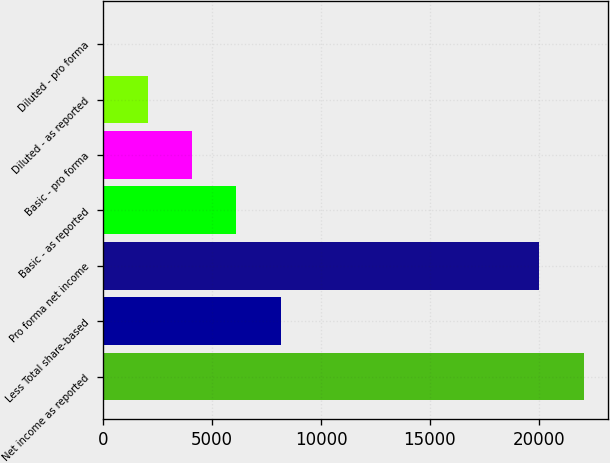Convert chart. <chart><loc_0><loc_0><loc_500><loc_500><bar_chart><fcel>Net income as reported<fcel>Less Total share-based<fcel>Pro forma net income<fcel>Basic - as reported<fcel>Basic - pro forma<fcel>Diluted - as reported<fcel>Diluted - pro forma<nl><fcel>22069.7<fcel>8154.93<fcel>20031<fcel>6116.25<fcel>4077.57<fcel>2038.89<fcel>0.21<nl></chart> 